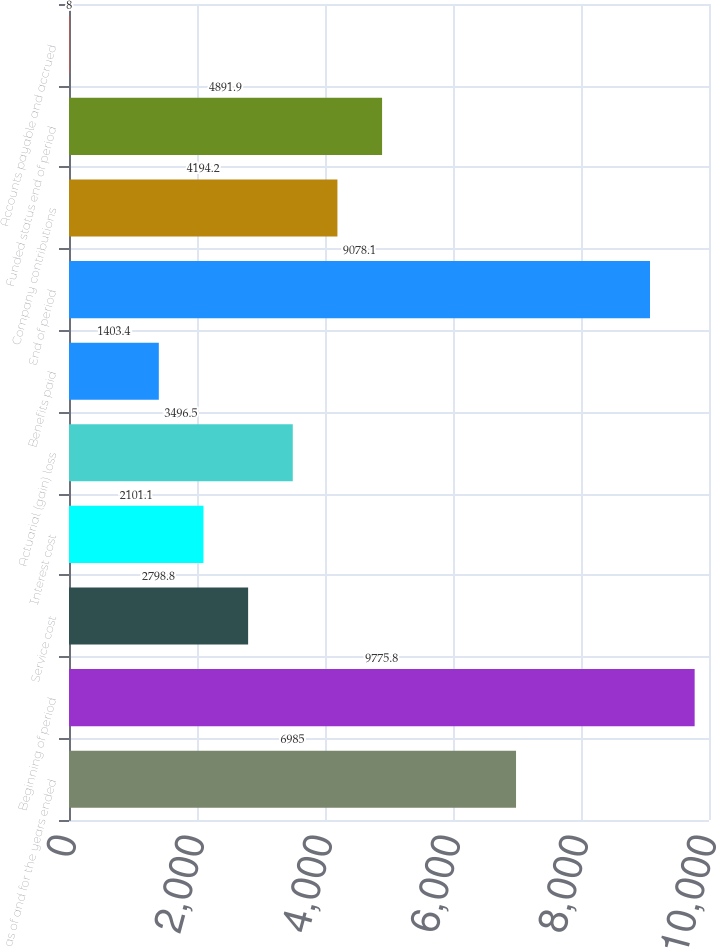Convert chart to OTSL. <chart><loc_0><loc_0><loc_500><loc_500><bar_chart><fcel>as of and for the years ended<fcel>Beginning of period<fcel>Service cost<fcel>Interest cost<fcel>Actuarial (gain) loss<fcel>Benefits paid<fcel>End of period<fcel>Company contributions<fcel>Funded status end of period<fcel>Accounts payable and accrued<nl><fcel>6985<fcel>9775.8<fcel>2798.8<fcel>2101.1<fcel>3496.5<fcel>1403.4<fcel>9078.1<fcel>4194.2<fcel>4891.9<fcel>8<nl></chart> 